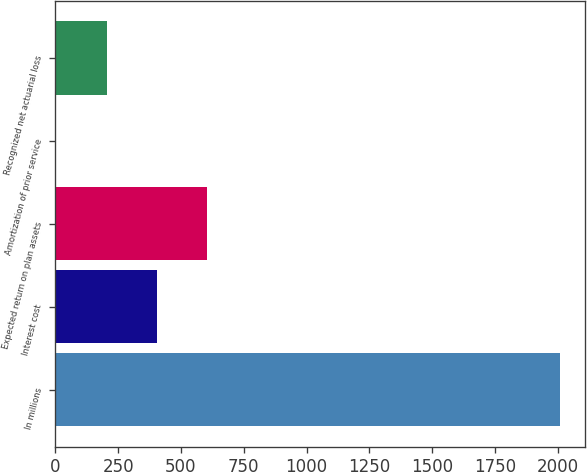<chart> <loc_0><loc_0><loc_500><loc_500><bar_chart><fcel>In millions<fcel>Interest cost<fcel>Expected return on plan assets<fcel>Amortization of prior service<fcel>Recognized net actuarial loss<nl><fcel>2008<fcel>404<fcel>604.5<fcel>3<fcel>203.5<nl></chart> 